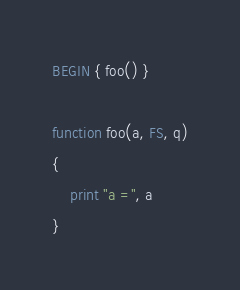<code> <loc_0><loc_0><loc_500><loc_500><_Awk_>BEGIN { foo() }

function foo(a, FS, q)
{
	print "a =", a
}
</code> 